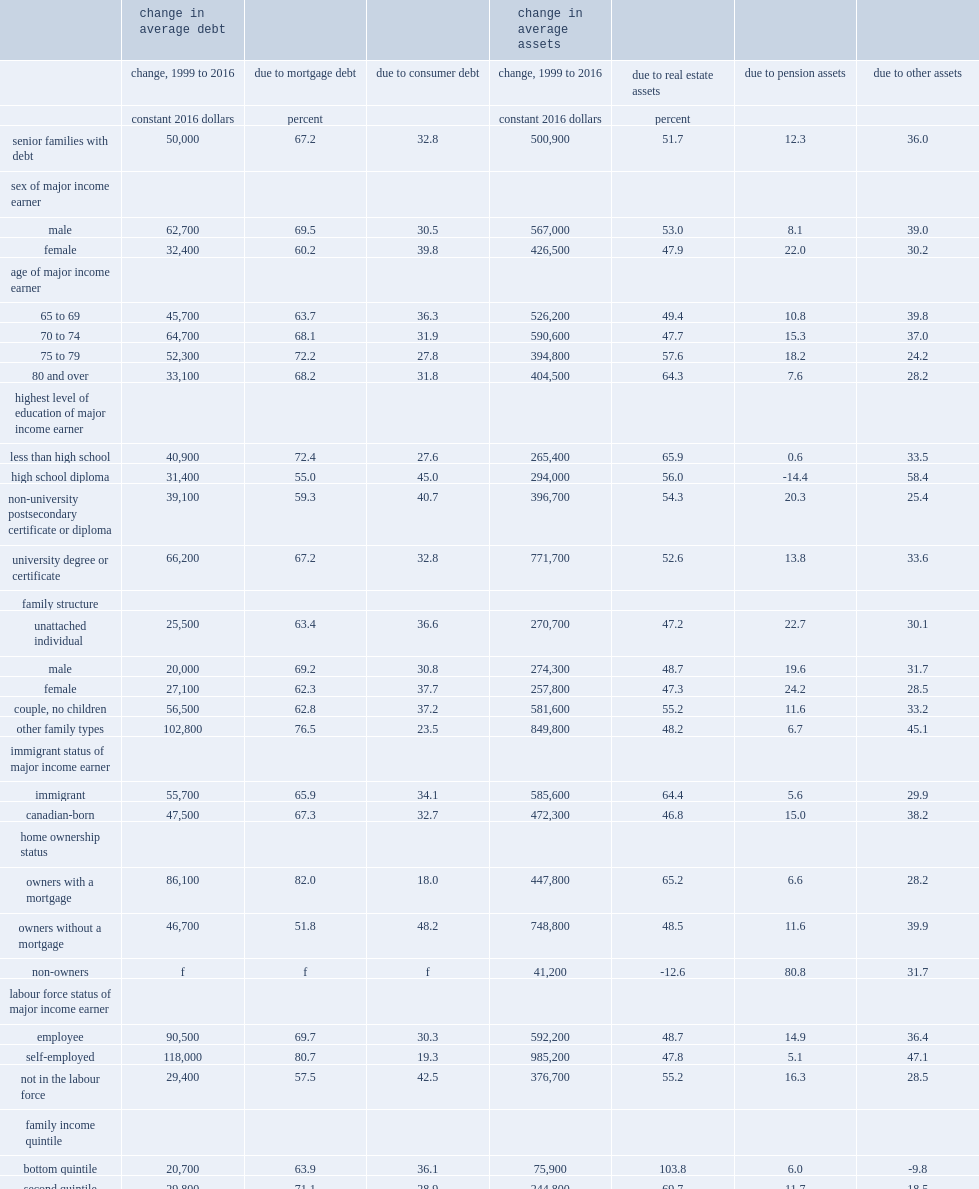What was the change in average debt and average assets between 1999 and 2016 respectively? 50000.0 500900.0. 